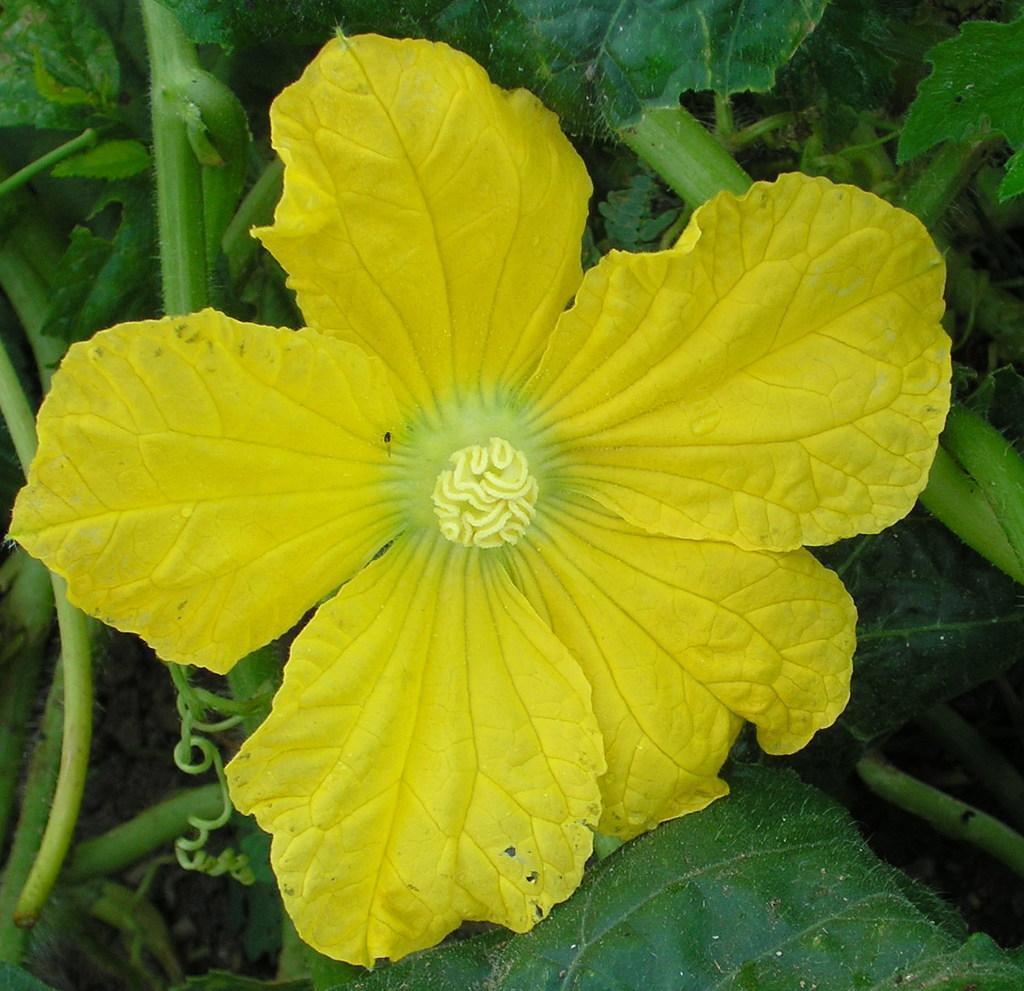Please provide a concise description of this image. In the center of the image there is a flower. At the background of the image there are leaves and stems. 